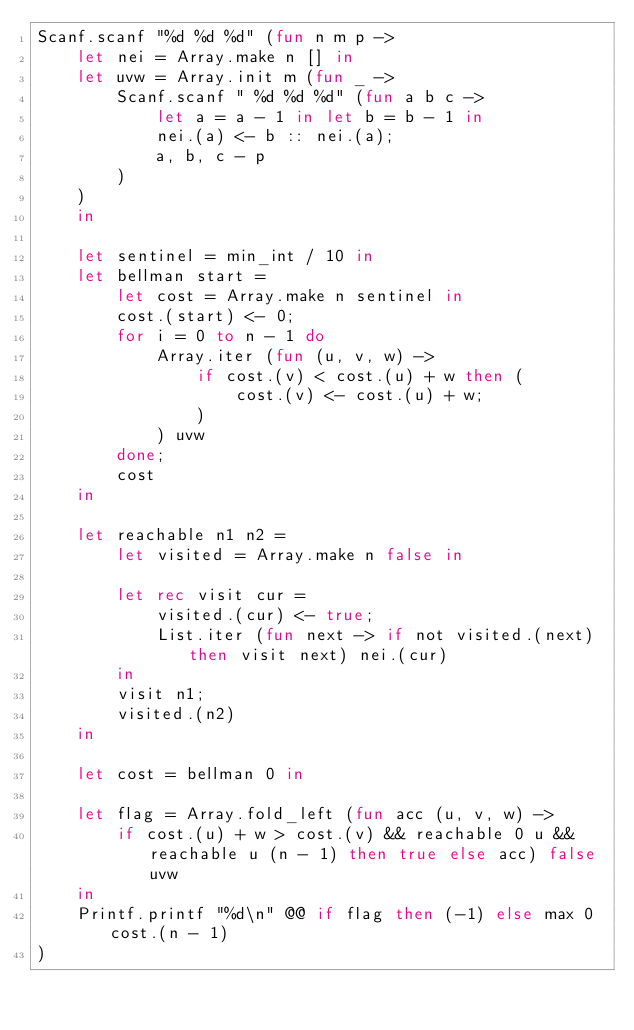Convert code to text. <code><loc_0><loc_0><loc_500><loc_500><_OCaml_>Scanf.scanf "%d %d %d" (fun n m p ->
    let nei = Array.make n [] in
    let uvw = Array.init m (fun _ ->
        Scanf.scanf " %d %d %d" (fun a b c ->
            let a = a - 1 in let b = b - 1 in
            nei.(a) <- b :: nei.(a);
            a, b, c - p
        )
    )
    in

    let sentinel = min_int / 10 in
    let bellman start =
        let cost = Array.make n sentinel in
        cost.(start) <- 0;
        for i = 0 to n - 1 do
            Array.iter (fun (u, v, w) ->
                if cost.(v) < cost.(u) + w then (
                    cost.(v) <- cost.(u) + w;
                )
            ) uvw
        done;
        cost
    in

    let reachable n1 n2 =
        let visited = Array.make n false in

        let rec visit cur =
            visited.(cur) <- true;
            List.iter (fun next -> if not visited.(next) then visit next) nei.(cur)
        in
        visit n1;
        visited.(n2)
    in

    let cost = bellman 0 in

    let flag = Array.fold_left (fun acc (u, v, w) ->
        if cost.(u) + w > cost.(v) && reachable 0 u && reachable u (n - 1) then true else acc) false uvw
    in
    Printf.printf "%d\n" @@ if flag then (-1) else max 0 cost.(n - 1)
)</code> 